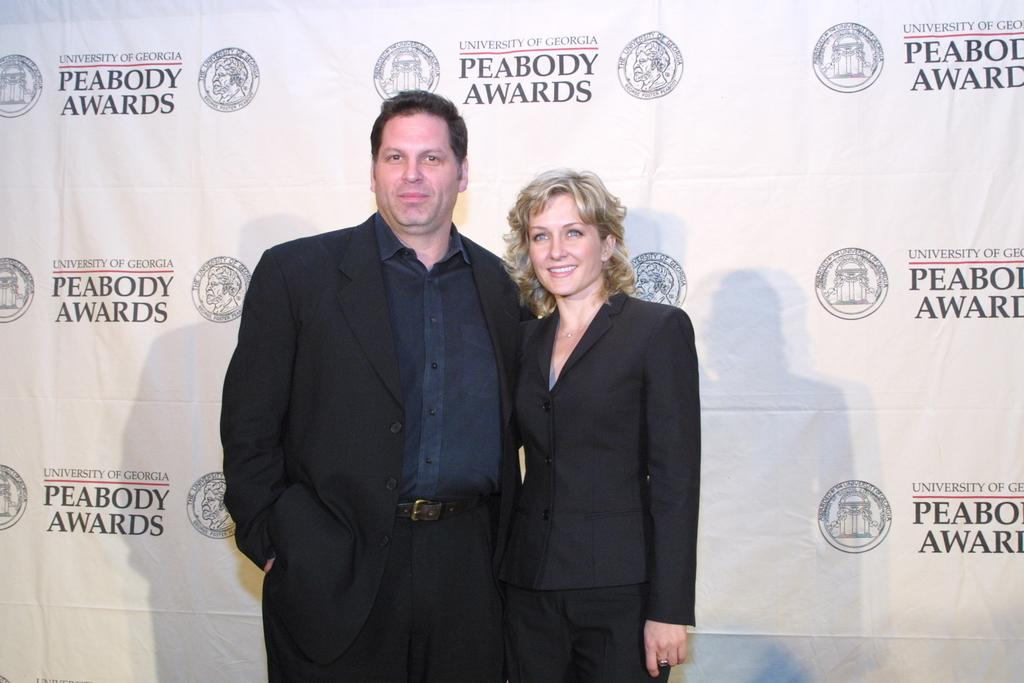What is the gender of the person in the image? There is a man in the image. What is the man wearing? The man is wearing a black dress. What is the facial expression of the man? The man is smiling. Who is the man standing near in the image? There is a woman in the image, and the man is standing near her. What is the woman wearing? The woman is wearing a black dress. What is the facial expression of the woman? The woman is smiling. What color is the banner in the background of the image? There is a white color banner in the background of the image. How many elbows can be seen in the image? There is no mention of elbows in the provided facts, so it is impossible to determine the number of elbows visible in the image. 